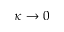Convert formula to latex. <formula><loc_0><loc_0><loc_500><loc_500>\kappa \rightarrow 0</formula> 